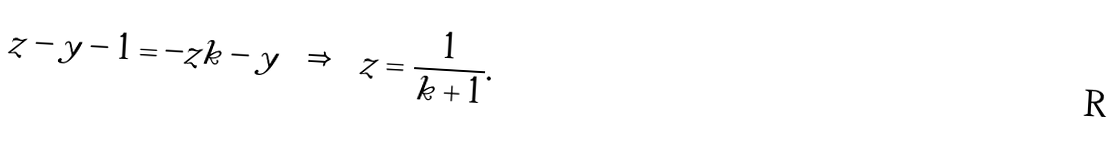<formula> <loc_0><loc_0><loc_500><loc_500>z - y - 1 = - z k - y \quad \Rightarrow \quad z = \frac { 1 } { k + 1 } .</formula> 